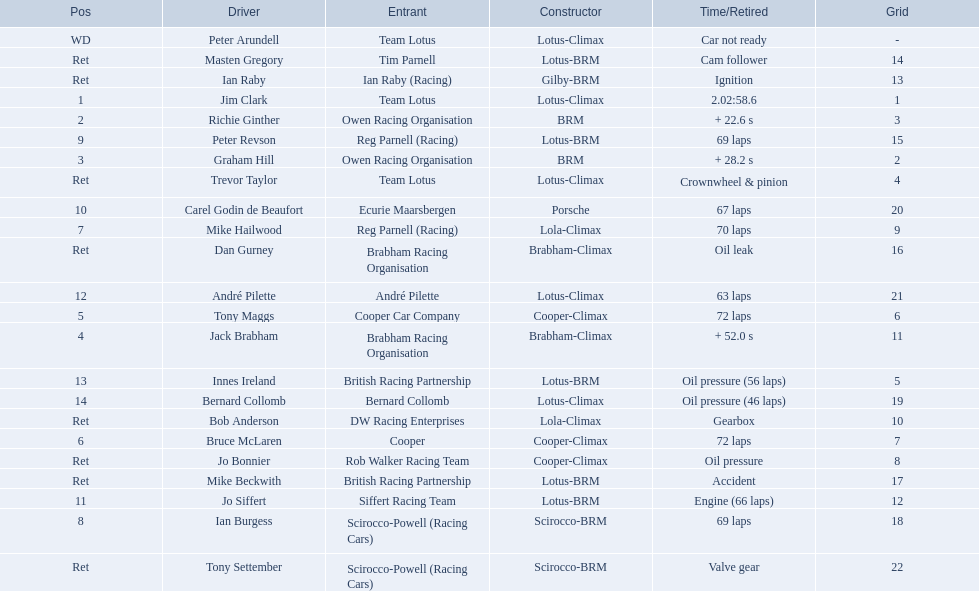Who drove in the 1963 international gold cup? Jim Clark, Richie Ginther, Graham Hill, Jack Brabham, Tony Maggs, Bruce McLaren, Mike Hailwood, Ian Burgess, Peter Revson, Carel Godin de Beaufort, Jo Siffert, André Pilette, Innes Ireland, Bernard Collomb, Ian Raby, Dan Gurney, Mike Beckwith, Masten Gregory, Trevor Taylor, Jo Bonnier, Tony Settember, Bob Anderson, Peter Arundell. Who had problems during the race? Jo Siffert, Innes Ireland, Bernard Collomb, Ian Raby, Dan Gurney, Mike Beckwith, Masten Gregory, Trevor Taylor, Jo Bonnier, Tony Settember, Bob Anderson, Peter Arundell. Of those who was still able to finish the race? Jo Siffert, Innes Ireland, Bernard Collomb. Of those who faced the same issue? Innes Ireland, Bernard Collomb. What issue did they have? Oil pressure. I'm looking to parse the entire table for insights. Could you assist me with that? {'header': ['Pos', 'Driver', 'Entrant', 'Constructor', 'Time/Retired', 'Grid'], 'rows': [['WD', 'Peter Arundell', 'Team Lotus', 'Lotus-Climax', 'Car not ready', '-'], ['Ret', 'Masten Gregory', 'Tim Parnell', 'Lotus-BRM', 'Cam follower', '14'], ['Ret', 'Ian Raby', 'Ian Raby (Racing)', 'Gilby-BRM', 'Ignition', '13'], ['1', 'Jim Clark', 'Team Lotus', 'Lotus-Climax', '2.02:58.6', '1'], ['2', 'Richie Ginther', 'Owen Racing Organisation', 'BRM', '+ 22.6 s', '3'], ['9', 'Peter Revson', 'Reg Parnell (Racing)', 'Lotus-BRM', '69 laps', '15'], ['3', 'Graham Hill', 'Owen Racing Organisation', 'BRM', '+ 28.2 s', '2'], ['Ret', 'Trevor Taylor', 'Team Lotus', 'Lotus-Climax', 'Crownwheel & pinion', '4'], ['10', 'Carel Godin de Beaufort', 'Ecurie Maarsbergen', 'Porsche', '67 laps', '20'], ['7', 'Mike Hailwood', 'Reg Parnell (Racing)', 'Lola-Climax', '70 laps', '9'], ['Ret', 'Dan Gurney', 'Brabham Racing Organisation', 'Brabham-Climax', 'Oil leak', '16'], ['12', 'André Pilette', 'André Pilette', 'Lotus-Climax', '63 laps', '21'], ['5', 'Tony Maggs', 'Cooper Car Company', 'Cooper-Climax', '72 laps', '6'], ['4', 'Jack Brabham', 'Brabham Racing Organisation', 'Brabham-Climax', '+ 52.0 s', '11'], ['13', 'Innes Ireland', 'British Racing Partnership', 'Lotus-BRM', 'Oil pressure (56 laps)', '5'], ['14', 'Bernard Collomb', 'Bernard Collomb', 'Lotus-Climax', 'Oil pressure (46 laps)', '19'], ['Ret', 'Bob Anderson', 'DW Racing Enterprises', 'Lola-Climax', 'Gearbox', '10'], ['6', 'Bruce McLaren', 'Cooper', 'Cooper-Climax', '72 laps', '7'], ['Ret', 'Jo Bonnier', 'Rob Walker Racing Team', 'Cooper-Climax', 'Oil pressure', '8'], ['Ret', 'Mike Beckwith', 'British Racing Partnership', 'Lotus-BRM', 'Accident', '17'], ['11', 'Jo Siffert', 'Siffert Racing Team', 'Lotus-BRM', 'Engine (66 laps)', '12'], ['8', 'Ian Burgess', 'Scirocco-Powell (Racing Cars)', 'Scirocco-BRM', '69 laps', '18'], ['Ret', 'Tony Settember', 'Scirocco-Powell (Racing Cars)', 'Scirocco-BRM', 'Valve gear', '22']]} 